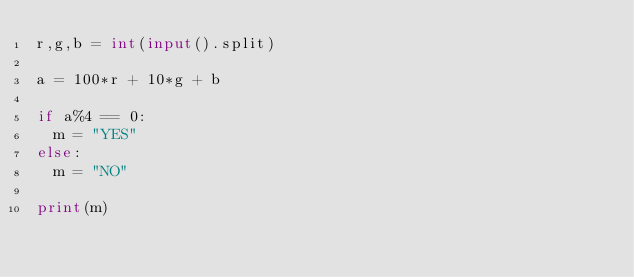<code> <loc_0><loc_0><loc_500><loc_500><_Python_>r,g,b = int(input().split)
 
a = 100*r + 10*g + b
 
if a%4 == 0:
  m = "YES"
else:
  m = "NO"
  
print(m)</code> 